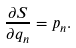Convert formula to latex. <formula><loc_0><loc_0><loc_500><loc_500>\frac { \partial S } { \partial q _ { n } } = p _ { n } .</formula> 